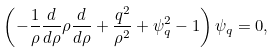Convert formula to latex. <formula><loc_0><loc_0><loc_500><loc_500>\left ( - \frac { 1 } { \rho } \frac { d } { d \rho } \rho \frac { d } { d \rho } + \frac { q ^ { 2 } } { \rho ^ { 2 } } + \psi _ { q } ^ { 2 } - 1 \right ) \psi _ { q } = 0 ,</formula> 